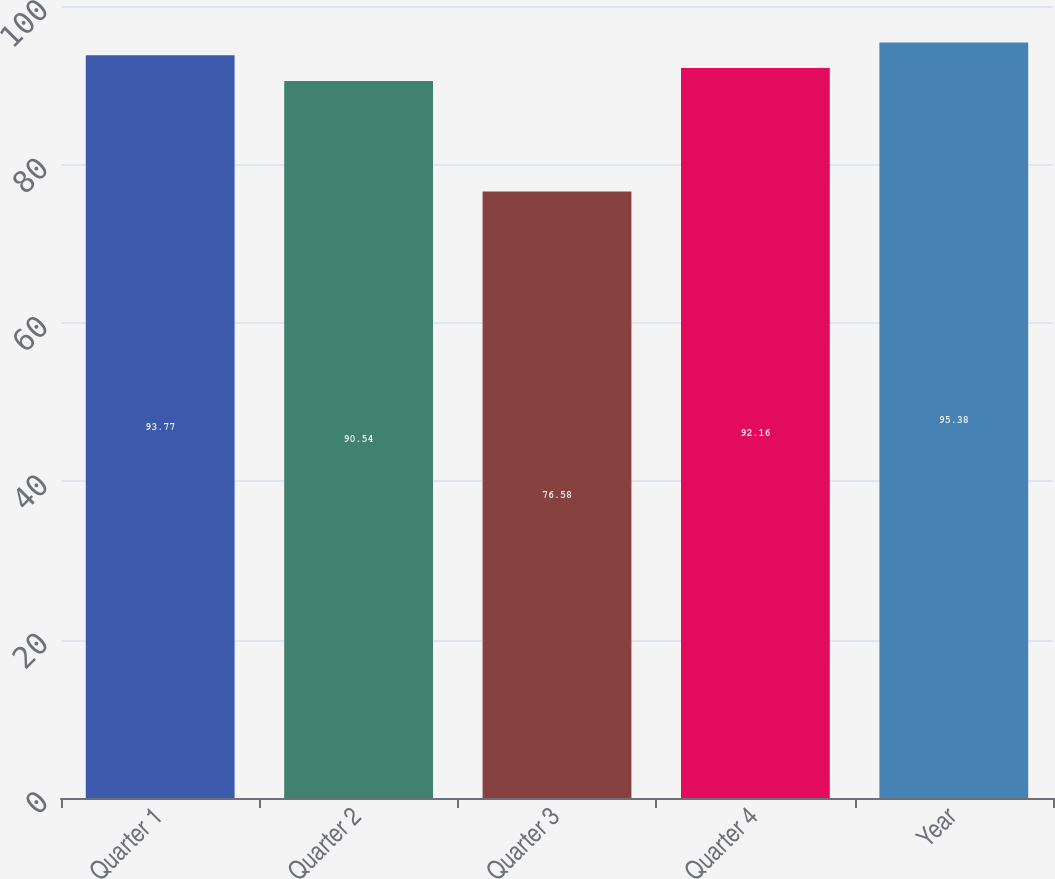Convert chart to OTSL. <chart><loc_0><loc_0><loc_500><loc_500><bar_chart><fcel>Quarter 1<fcel>Quarter 2<fcel>Quarter 3<fcel>Quarter 4<fcel>Year<nl><fcel>93.77<fcel>90.54<fcel>76.58<fcel>92.16<fcel>95.38<nl></chart> 